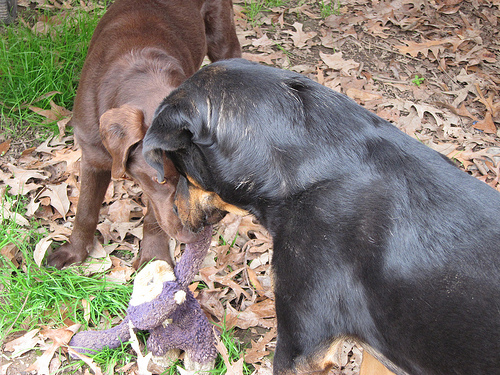<image>
Is there a brown dog to the right of the black dog? No. The brown dog is not to the right of the black dog. The horizontal positioning shows a different relationship. 